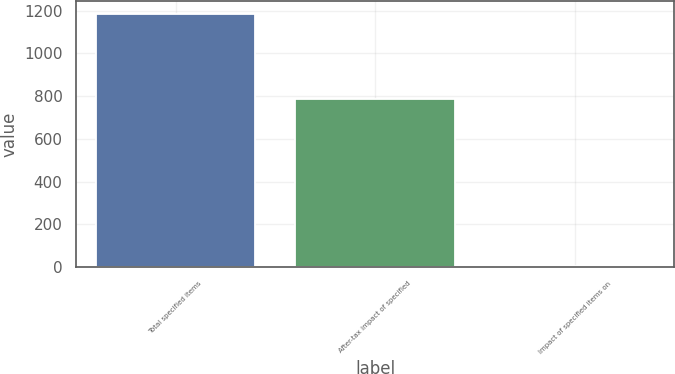Convert chart to OTSL. <chart><loc_0><loc_0><loc_500><loc_500><bar_chart><fcel>Total specified items<fcel>After-tax impact of specified<fcel>Impact of specified items on<nl><fcel>1186<fcel>786<fcel>3.79<nl></chart> 